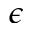Convert formula to latex. <formula><loc_0><loc_0><loc_500><loc_500>\epsilon</formula> 